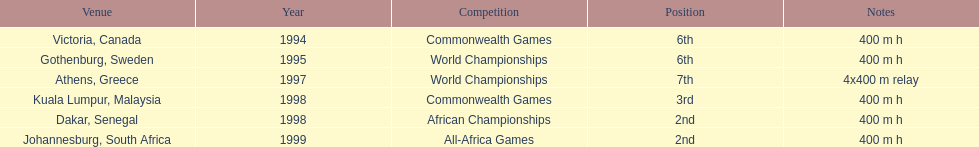Which year had the most competitions? 1998. 